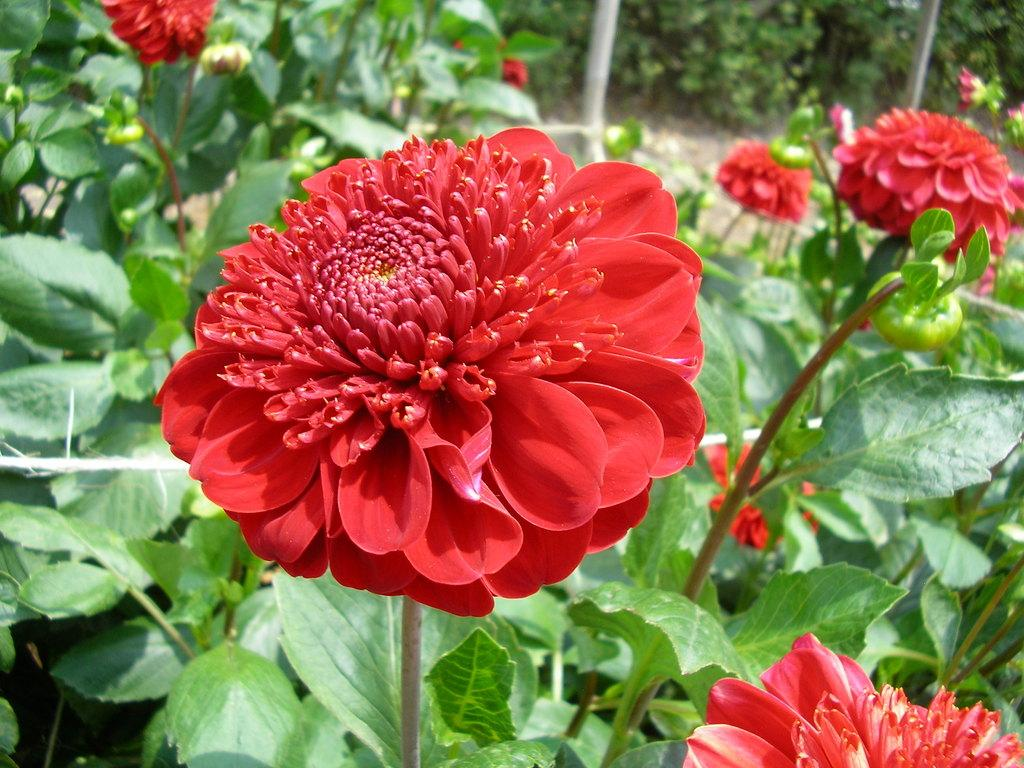What type of living organisms can be seen in the image? Plants and flowers are visible in the image. What color are the flowers in the image? The flowers in the image are red in color. Where is the baby located in the image? There is no baby present in the image. What type of building can be seen in the image? There is no building present in the image. 